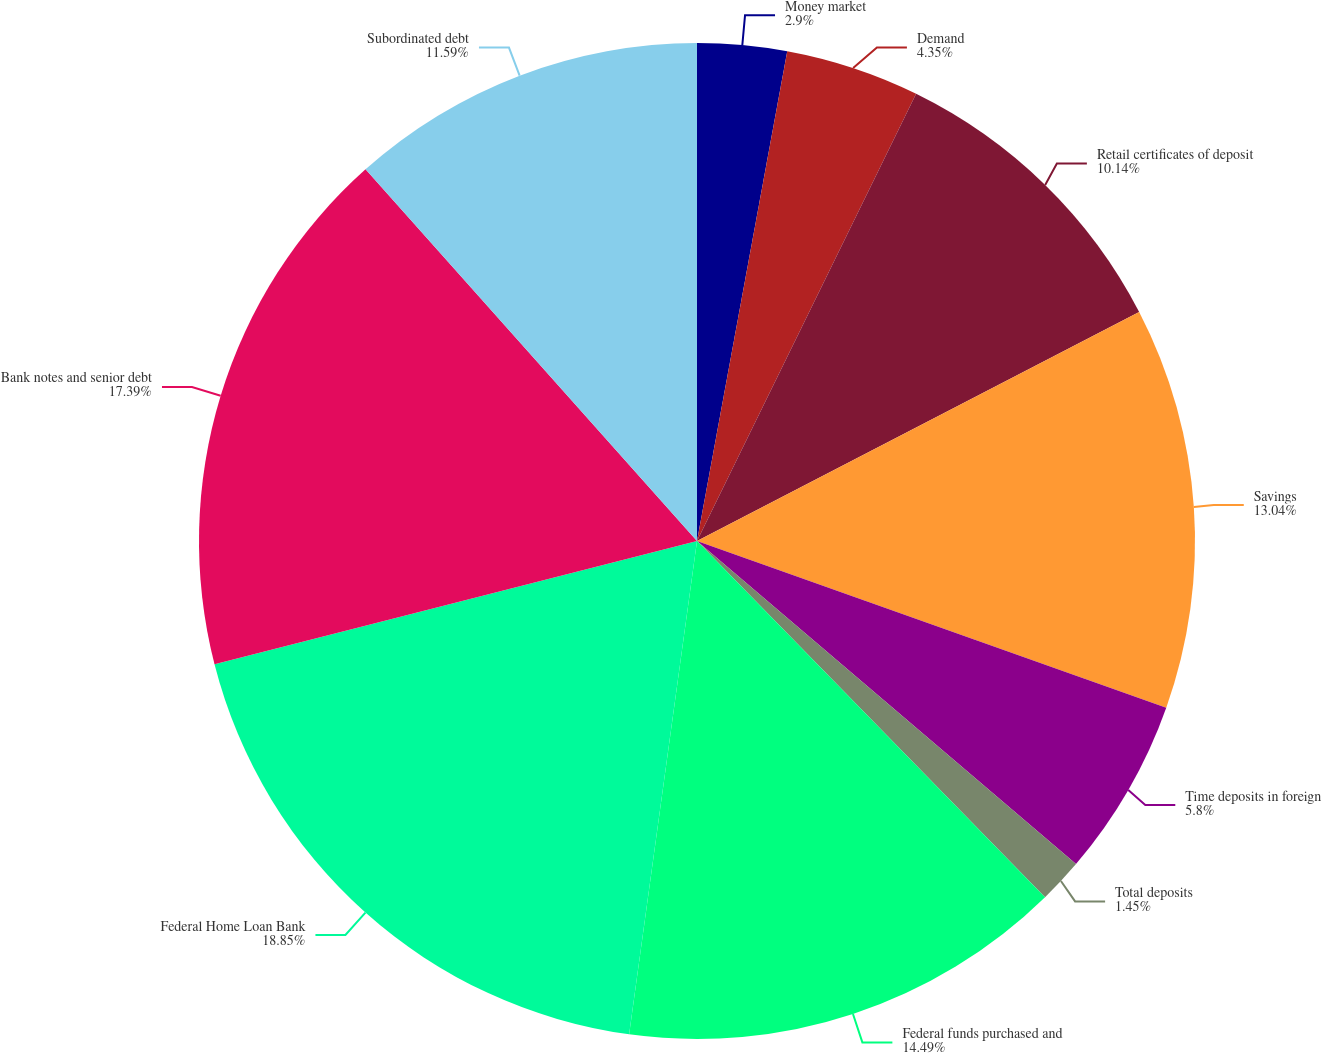Convert chart. <chart><loc_0><loc_0><loc_500><loc_500><pie_chart><fcel>Money market<fcel>Demand<fcel>Retail certificates of deposit<fcel>Savings<fcel>Time deposits in foreign<fcel>Total deposits<fcel>Federal funds purchased and<fcel>Federal Home Loan Bank<fcel>Bank notes and senior debt<fcel>Subordinated debt<nl><fcel>2.9%<fcel>4.35%<fcel>10.14%<fcel>13.04%<fcel>5.8%<fcel>1.45%<fcel>14.49%<fcel>18.84%<fcel>17.39%<fcel>11.59%<nl></chart> 